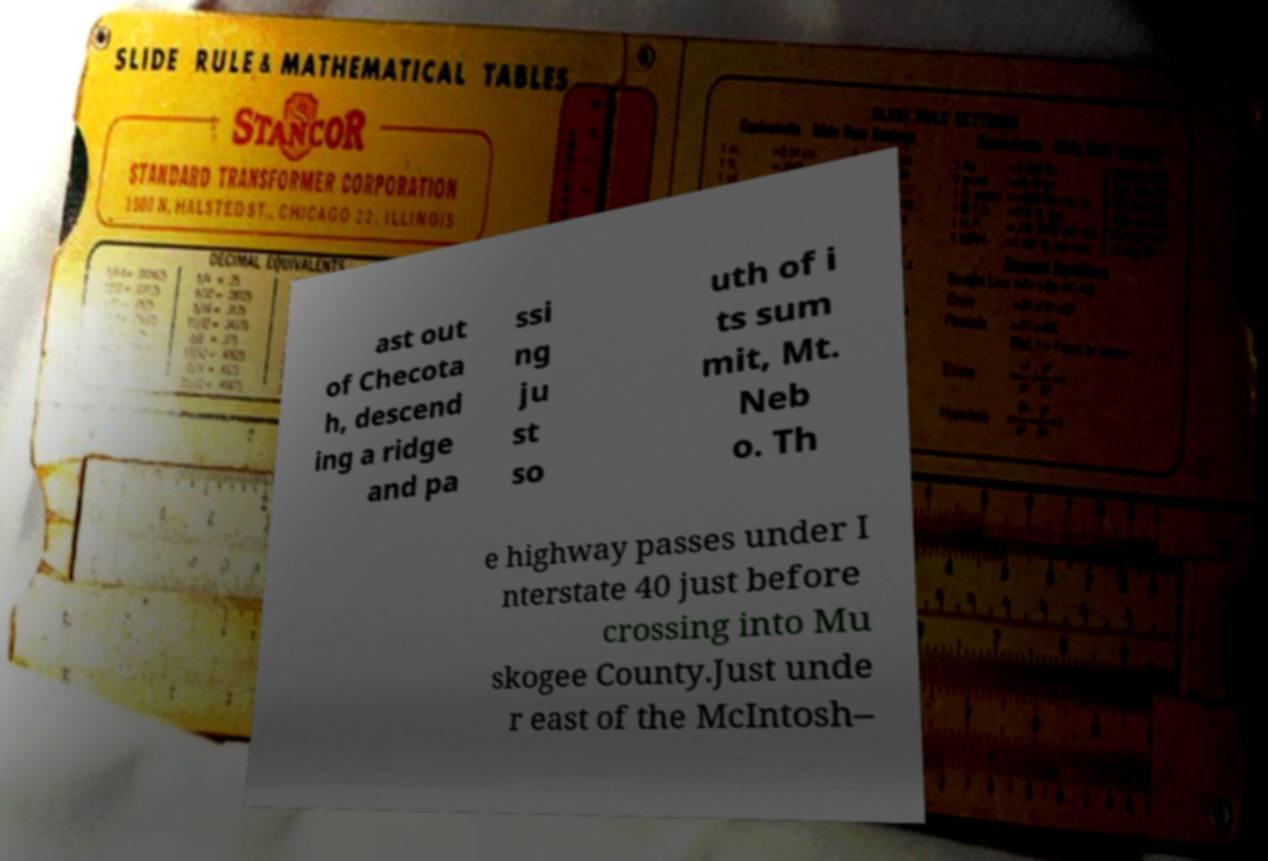Could you extract and type out the text from this image? ast out of Checota h, descend ing a ridge and pa ssi ng ju st so uth of i ts sum mit, Mt. Neb o. Th e highway passes under I nterstate 40 just before crossing into Mu skogee County.Just unde r east of the McIntosh– 